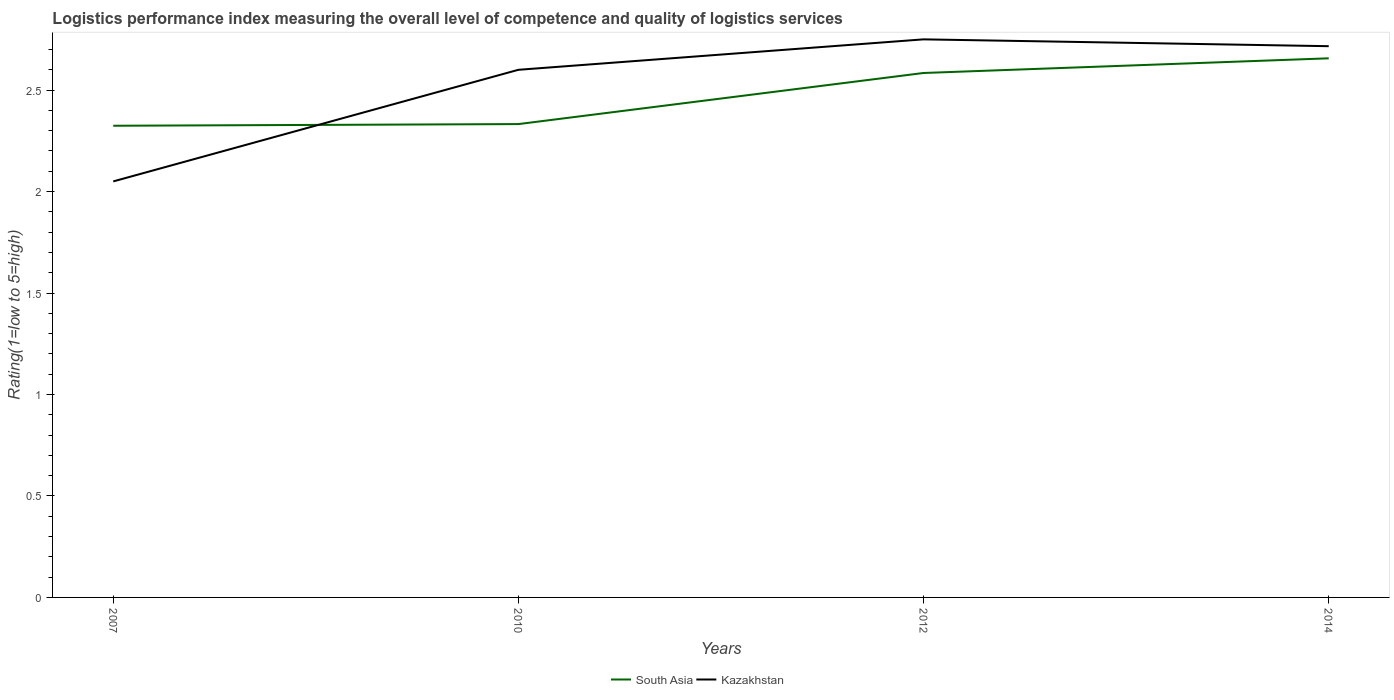How many different coloured lines are there?
Your answer should be very brief. 2. Does the line corresponding to Kazakhstan intersect with the line corresponding to South Asia?
Your answer should be compact. Yes. Across all years, what is the maximum Logistic performance index in Kazakhstan?
Your answer should be compact. 2.05. What is the total Logistic performance index in South Asia in the graph?
Offer a terse response. -0.25. What is the difference between the highest and the second highest Logistic performance index in South Asia?
Your answer should be very brief. 0.33. What is the difference between the highest and the lowest Logistic performance index in South Asia?
Keep it short and to the point. 2. Is the Logistic performance index in Kazakhstan strictly greater than the Logistic performance index in South Asia over the years?
Your answer should be compact. No. How many lines are there?
Offer a very short reply. 2. Does the graph contain grids?
Offer a terse response. No. Where does the legend appear in the graph?
Ensure brevity in your answer.  Bottom center. How many legend labels are there?
Give a very brief answer. 2. What is the title of the graph?
Your answer should be compact. Logistics performance index measuring the overall level of competence and quality of logistics services. Does "Belize" appear as one of the legend labels in the graph?
Provide a short and direct response. No. What is the label or title of the X-axis?
Provide a short and direct response. Years. What is the label or title of the Y-axis?
Your answer should be very brief. Rating(1=low to 5=high). What is the Rating(1=low to 5=high) in South Asia in 2007?
Provide a short and direct response. 2.32. What is the Rating(1=low to 5=high) of Kazakhstan in 2007?
Provide a short and direct response. 2.05. What is the Rating(1=low to 5=high) of South Asia in 2010?
Offer a terse response. 2.33. What is the Rating(1=low to 5=high) of South Asia in 2012?
Ensure brevity in your answer.  2.58. What is the Rating(1=low to 5=high) in Kazakhstan in 2012?
Provide a short and direct response. 2.75. What is the Rating(1=low to 5=high) in South Asia in 2014?
Make the answer very short. 2.66. What is the Rating(1=low to 5=high) in Kazakhstan in 2014?
Keep it short and to the point. 2.72. Across all years, what is the maximum Rating(1=low to 5=high) in South Asia?
Provide a short and direct response. 2.66. Across all years, what is the maximum Rating(1=low to 5=high) in Kazakhstan?
Your response must be concise. 2.75. Across all years, what is the minimum Rating(1=low to 5=high) of South Asia?
Your answer should be very brief. 2.32. Across all years, what is the minimum Rating(1=low to 5=high) of Kazakhstan?
Provide a short and direct response. 2.05. What is the total Rating(1=low to 5=high) of South Asia in the graph?
Offer a terse response. 9.9. What is the total Rating(1=low to 5=high) of Kazakhstan in the graph?
Offer a terse response. 10.12. What is the difference between the Rating(1=low to 5=high) in South Asia in 2007 and that in 2010?
Give a very brief answer. -0.01. What is the difference between the Rating(1=low to 5=high) in Kazakhstan in 2007 and that in 2010?
Your answer should be very brief. -0.55. What is the difference between the Rating(1=low to 5=high) of South Asia in 2007 and that in 2012?
Provide a succinct answer. -0.26. What is the difference between the Rating(1=low to 5=high) of South Asia in 2007 and that in 2014?
Give a very brief answer. -0.33. What is the difference between the Rating(1=low to 5=high) of Kazakhstan in 2007 and that in 2014?
Give a very brief answer. -0.67. What is the difference between the Rating(1=low to 5=high) of South Asia in 2010 and that in 2012?
Make the answer very short. -0.25. What is the difference between the Rating(1=low to 5=high) in Kazakhstan in 2010 and that in 2012?
Provide a succinct answer. -0.15. What is the difference between the Rating(1=low to 5=high) of South Asia in 2010 and that in 2014?
Keep it short and to the point. -0.32. What is the difference between the Rating(1=low to 5=high) in Kazakhstan in 2010 and that in 2014?
Offer a terse response. -0.12. What is the difference between the Rating(1=low to 5=high) in South Asia in 2012 and that in 2014?
Ensure brevity in your answer.  -0.07. What is the difference between the Rating(1=low to 5=high) of Kazakhstan in 2012 and that in 2014?
Provide a short and direct response. 0.03. What is the difference between the Rating(1=low to 5=high) in South Asia in 2007 and the Rating(1=low to 5=high) in Kazakhstan in 2010?
Your answer should be compact. -0.28. What is the difference between the Rating(1=low to 5=high) of South Asia in 2007 and the Rating(1=low to 5=high) of Kazakhstan in 2012?
Make the answer very short. -0.43. What is the difference between the Rating(1=low to 5=high) of South Asia in 2007 and the Rating(1=low to 5=high) of Kazakhstan in 2014?
Keep it short and to the point. -0.39. What is the difference between the Rating(1=low to 5=high) in South Asia in 2010 and the Rating(1=low to 5=high) in Kazakhstan in 2012?
Your answer should be very brief. -0.42. What is the difference between the Rating(1=low to 5=high) in South Asia in 2010 and the Rating(1=low to 5=high) in Kazakhstan in 2014?
Offer a very short reply. -0.38. What is the difference between the Rating(1=low to 5=high) in South Asia in 2012 and the Rating(1=low to 5=high) in Kazakhstan in 2014?
Your answer should be compact. -0.13. What is the average Rating(1=low to 5=high) in South Asia per year?
Your response must be concise. 2.47. What is the average Rating(1=low to 5=high) of Kazakhstan per year?
Give a very brief answer. 2.53. In the year 2007, what is the difference between the Rating(1=low to 5=high) of South Asia and Rating(1=low to 5=high) of Kazakhstan?
Give a very brief answer. 0.27. In the year 2010, what is the difference between the Rating(1=low to 5=high) in South Asia and Rating(1=low to 5=high) in Kazakhstan?
Ensure brevity in your answer.  -0.27. In the year 2012, what is the difference between the Rating(1=low to 5=high) in South Asia and Rating(1=low to 5=high) in Kazakhstan?
Make the answer very short. -0.17. In the year 2014, what is the difference between the Rating(1=low to 5=high) in South Asia and Rating(1=low to 5=high) in Kazakhstan?
Make the answer very short. -0.06. What is the ratio of the Rating(1=low to 5=high) of Kazakhstan in 2007 to that in 2010?
Ensure brevity in your answer.  0.79. What is the ratio of the Rating(1=low to 5=high) in South Asia in 2007 to that in 2012?
Offer a terse response. 0.9. What is the ratio of the Rating(1=low to 5=high) of Kazakhstan in 2007 to that in 2012?
Ensure brevity in your answer.  0.75. What is the ratio of the Rating(1=low to 5=high) in South Asia in 2007 to that in 2014?
Ensure brevity in your answer.  0.87. What is the ratio of the Rating(1=low to 5=high) of Kazakhstan in 2007 to that in 2014?
Make the answer very short. 0.75. What is the ratio of the Rating(1=low to 5=high) in South Asia in 2010 to that in 2012?
Make the answer very short. 0.9. What is the ratio of the Rating(1=low to 5=high) of Kazakhstan in 2010 to that in 2012?
Keep it short and to the point. 0.95. What is the ratio of the Rating(1=low to 5=high) in South Asia in 2010 to that in 2014?
Provide a short and direct response. 0.88. What is the ratio of the Rating(1=low to 5=high) of Kazakhstan in 2010 to that in 2014?
Offer a very short reply. 0.96. What is the ratio of the Rating(1=low to 5=high) in South Asia in 2012 to that in 2014?
Keep it short and to the point. 0.97. What is the ratio of the Rating(1=low to 5=high) of Kazakhstan in 2012 to that in 2014?
Offer a terse response. 1.01. What is the difference between the highest and the second highest Rating(1=low to 5=high) in South Asia?
Your answer should be very brief. 0.07. What is the difference between the highest and the second highest Rating(1=low to 5=high) of Kazakhstan?
Keep it short and to the point. 0.03. What is the difference between the highest and the lowest Rating(1=low to 5=high) in South Asia?
Your answer should be compact. 0.33. 